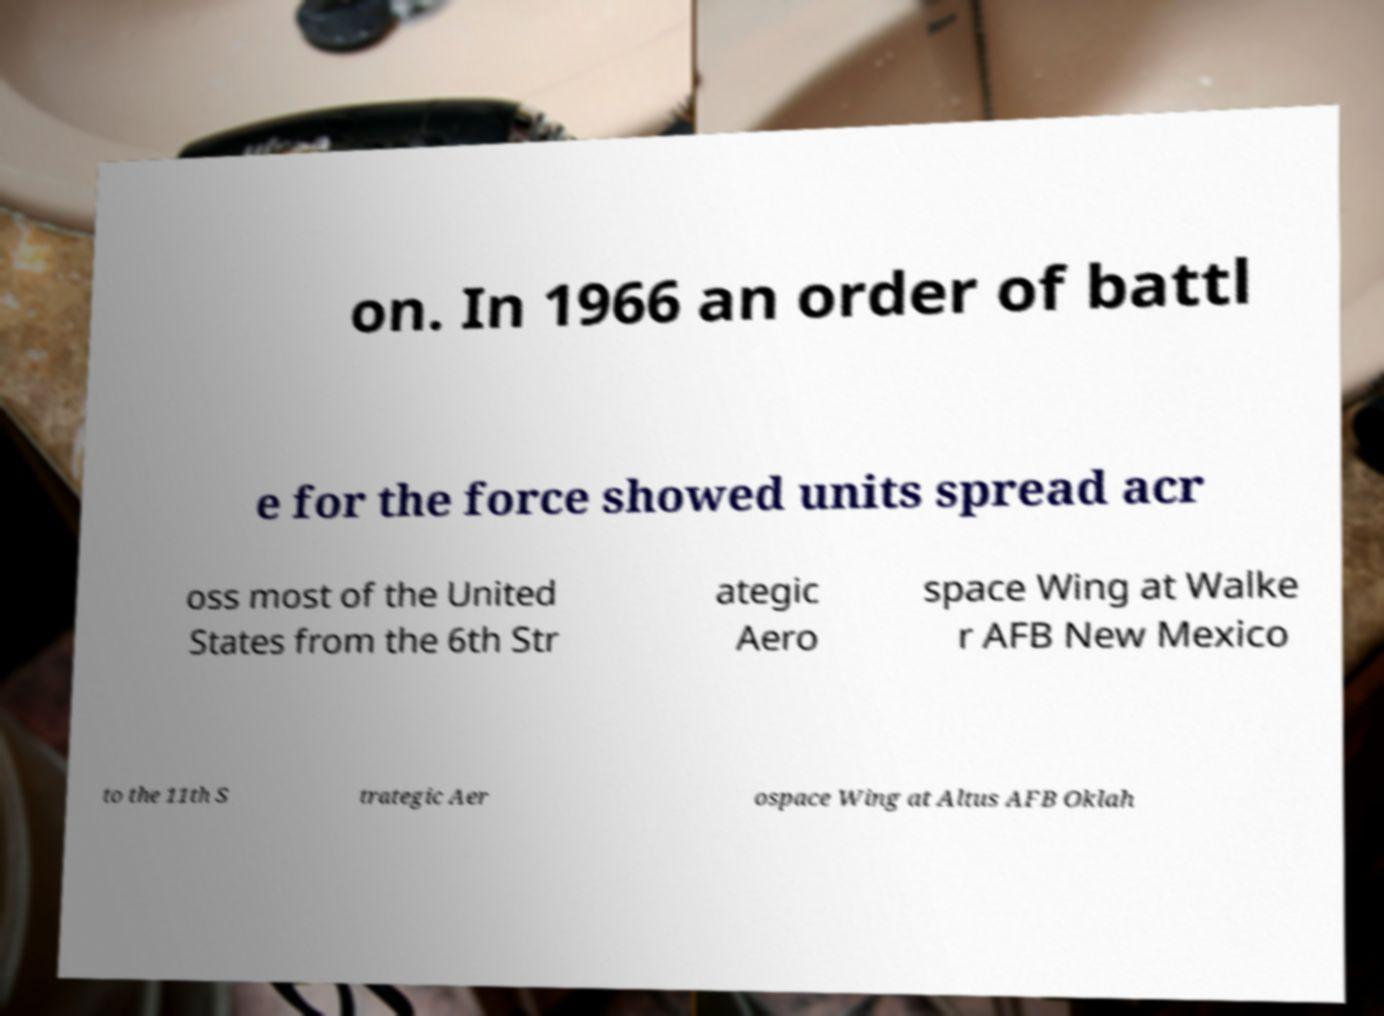What messages or text are displayed in this image? I need them in a readable, typed format. on. In 1966 an order of battl e for the force showed units spread acr oss most of the United States from the 6th Str ategic Aero space Wing at Walke r AFB New Mexico to the 11th S trategic Aer ospace Wing at Altus AFB Oklah 